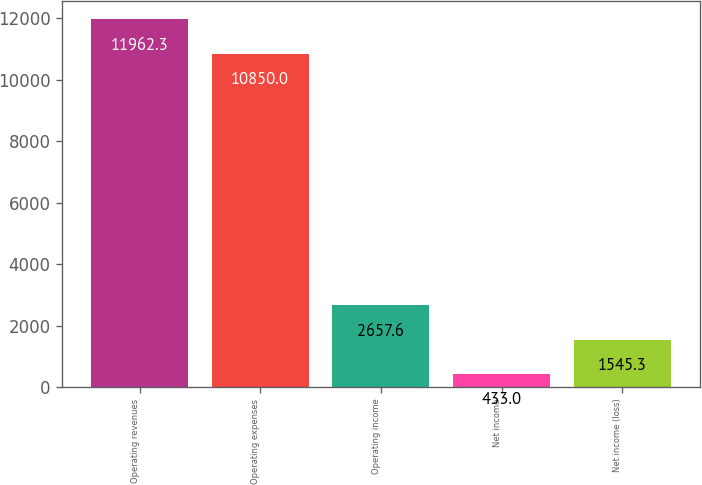<chart> <loc_0><loc_0><loc_500><loc_500><bar_chart><fcel>Operating revenues<fcel>Operating expenses<fcel>Operating income<fcel>Net income<fcel>Net income (loss)<nl><fcel>11962.3<fcel>10850<fcel>2657.6<fcel>433<fcel>1545.3<nl></chart> 